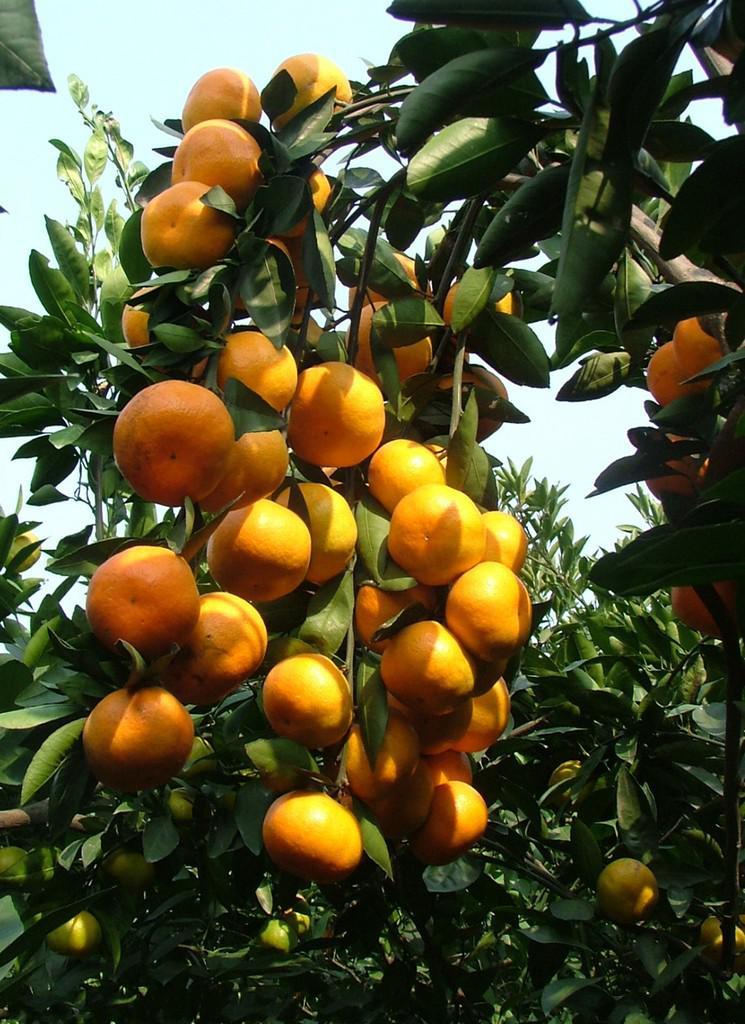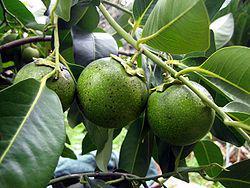The first image is the image on the left, the second image is the image on the right. Evaluate the accuracy of this statement regarding the images: "Yellow citrus fruit grow in the tree in the image on the left.". Is it true? Answer yes or no. Yes. 